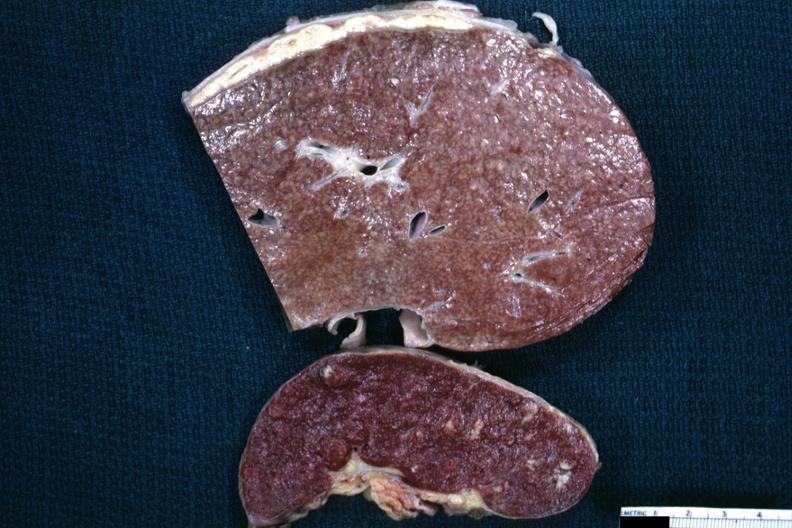what contains granulomata slide is a close-up view of the typical cold abscess exudate on the liver surface?
Answer the question using a single word or phrase. Slices and spleen tuberculous present capsule and spleen 